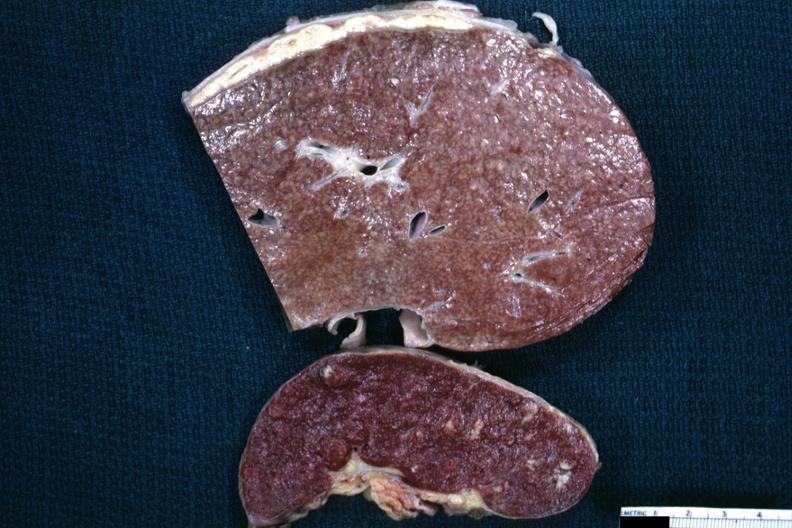what contains granulomata slide is a close-up view of the typical cold abscess exudate on the liver surface?
Answer the question using a single word or phrase. Slices and spleen tuberculous present capsule and spleen 